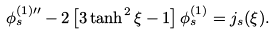Convert formula to latex. <formula><loc_0><loc_0><loc_500><loc_500>\phi ^ { ( 1 ) \prime \prime } _ { s } - 2 \left [ 3 \tanh ^ { 2 } \xi - 1 \right ] \phi ^ { ( 1 ) } _ { s } = j _ { s } ( \xi ) .</formula> 